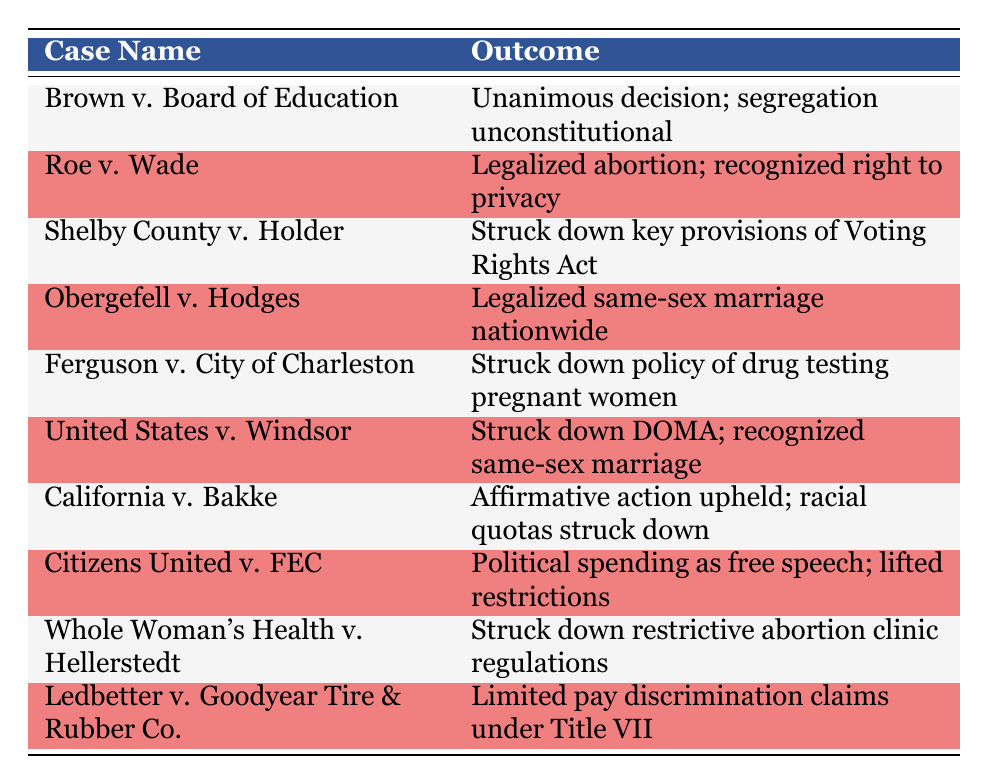What is the outcome of Brown v. Board of Education? The table lists the outcome for Brown v. Board of Education clearly, stating it was a "Unanimous decision; segregation unconstitutional."
Answer: Unanimous decision; segregation unconstitutional How many cases in the table resulted in the legalization of something? The cases that resulted in legalization are Roe v. Wade (abortion), Obergefell v. Hodges (same-sex marriage), and United States v. Windsor (same-sex marriage), totaling three cases.
Answer: 3 cases Did the United States Supreme Court strike down any key provisions of the Voting Rights Act? Referring to the table, Shelby County v. Holder is explicitly listed as having "Struck down key provisions of Voting Rights Act."
Answer: Yes Which cases specifically dealt with same-sex marriage? The table shows two cases that are specifically related to same-sex marriage: Obergefell v. Hodges and United States v. Windsor, indicating they both legalized it.
Answer: Obergefell v. Hodges and United States v. Windsor Which outcome was related to the right to privacy? The outcome that mentions the right to privacy is associated with Roe v. Wade, which states it "Legalized abortion; recognized right to privacy."
Answer: Legalized abortion; recognized right to privacy How many cases mentioned policies being struck down? To determine this, we look for any mention of striking down policies in the table. The cases Shelby County v. Holder, Ferguson v. City of Charleston, Whole Woman's Health v. Hellerstedt, and Ledbetter v. Goodyear Tire & Rubber Co. can be counted, adding up to four cases that indicate policies were struck down.
Answer: 4 cases Which case involved the issue of affirmative action? The table indicates that California v. Bakke dealt with affirmative action, as the outcome states "Affirmative action upheld; racial quotas struck down."
Answer: California v. Bakke What is the outcome of Ledbetter v. Goodyear Tire & Rubber Co.? The specific outcome for Ledbetter v. Goodyear Tire & Rubber Co. described in the table is "Limited pay discrimination claims under Title VII."
Answer: Limited pay discrimination claims under Title VII Which case had an outcome related to political spending and free speech? According to the table, Citizens United v. FEC is associated with political spending, stating "Political spending as free speech; lifted restrictions."
Answer: Citizens United v. FEC 